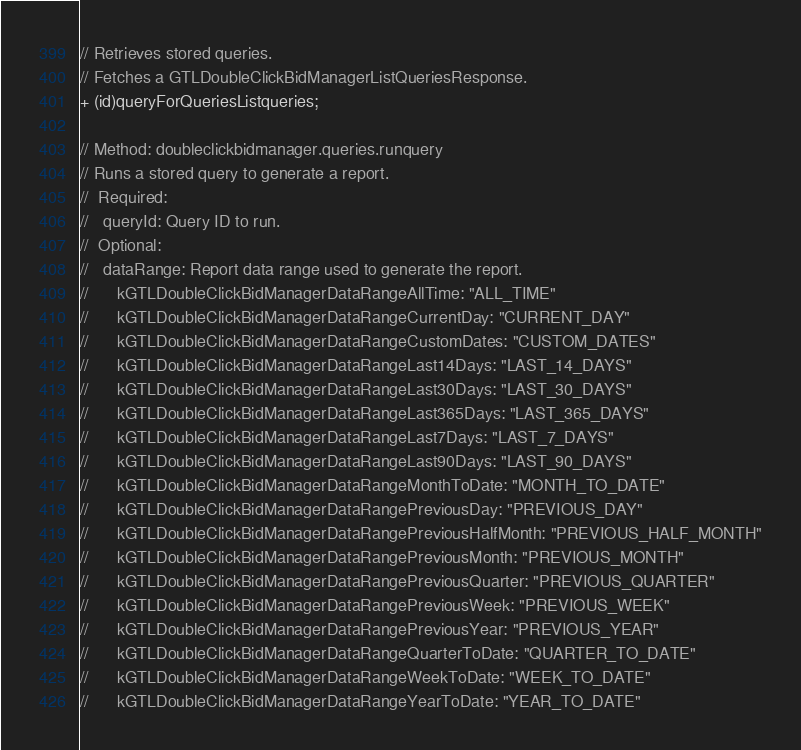Convert code to text. <code><loc_0><loc_0><loc_500><loc_500><_C_>// Retrieves stored queries.
// Fetches a GTLDoubleClickBidManagerListQueriesResponse.
+ (id)queryForQueriesListqueries;

// Method: doubleclickbidmanager.queries.runquery
// Runs a stored query to generate a report.
//  Required:
//   queryId: Query ID to run.
//  Optional:
//   dataRange: Report data range used to generate the report.
//      kGTLDoubleClickBidManagerDataRangeAllTime: "ALL_TIME"
//      kGTLDoubleClickBidManagerDataRangeCurrentDay: "CURRENT_DAY"
//      kGTLDoubleClickBidManagerDataRangeCustomDates: "CUSTOM_DATES"
//      kGTLDoubleClickBidManagerDataRangeLast14Days: "LAST_14_DAYS"
//      kGTLDoubleClickBidManagerDataRangeLast30Days: "LAST_30_DAYS"
//      kGTLDoubleClickBidManagerDataRangeLast365Days: "LAST_365_DAYS"
//      kGTLDoubleClickBidManagerDataRangeLast7Days: "LAST_7_DAYS"
//      kGTLDoubleClickBidManagerDataRangeLast90Days: "LAST_90_DAYS"
//      kGTLDoubleClickBidManagerDataRangeMonthToDate: "MONTH_TO_DATE"
//      kGTLDoubleClickBidManagerDataRangePreviousDay: "PREVIOUS_DAY"
//      kGTLDoubleClickBidManagerDataRangePreviousHalfMonth: "PREVIOUS_HALF_MONTH"
//      kGTLDoubleClickBidManagerDataRangePreviousMonth: "PREVIOUS_MONTH"
//      kGTLDoubleClickBidManagerDataRangePreviousQuarter: "PREVIOUS_QUARTER"
//      kGTLDoubleClickBidManagerDataRangePreviousWeek: "PREVIOUS_WEEK"
//      kGTLDoubleClickBidManagerDataRangePreviousYear: "PREVIOUS_YEAR"
//      kGTLDoubleClickBidManagerDataRangeQuarterToDate: "QUARTER_TO_DATE"
//      kGTLDoubleClickBidManagerDataRangeWeekToDate: "WEEK_TO_DATE"
//      kGTLDoubleClickBidManagerDataRangeYearToDate: "YEAR_TO_DATE"</code> 